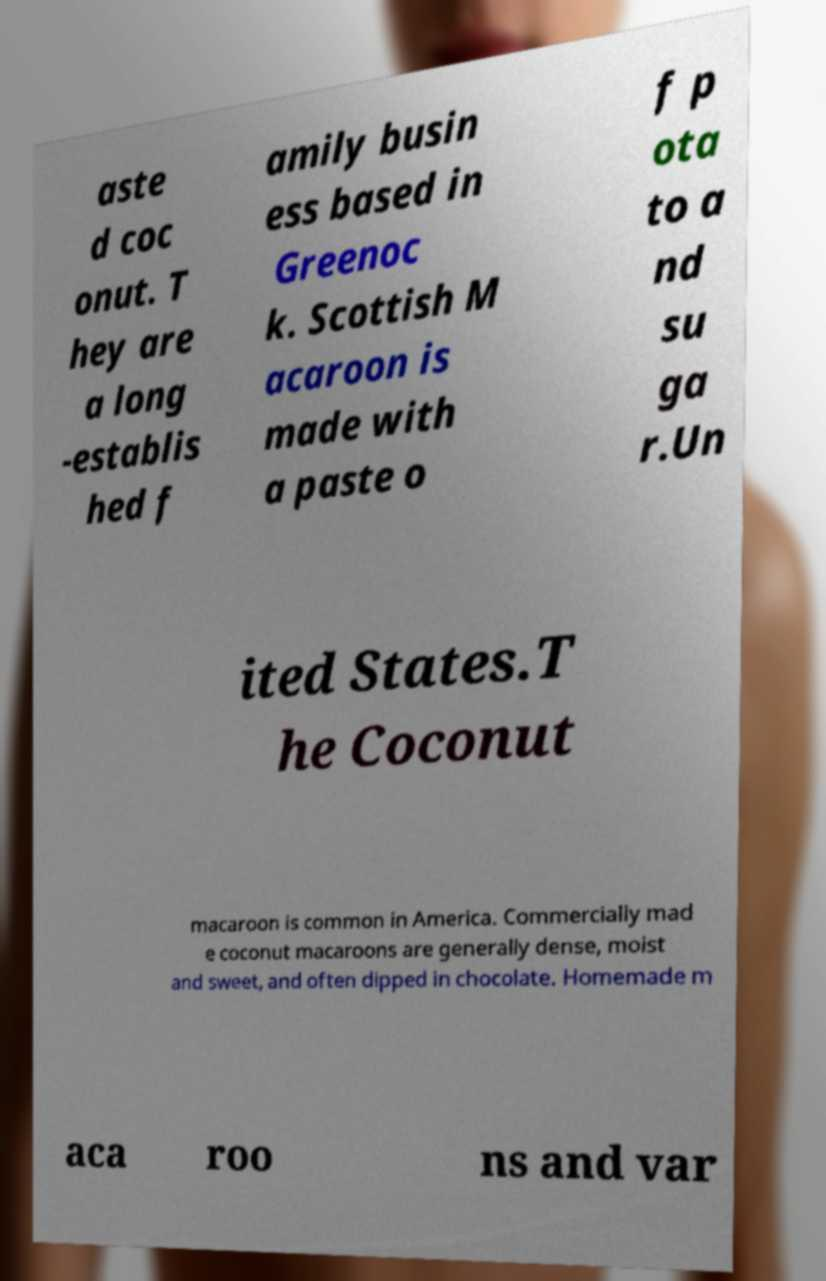Can you accurately transcribe the text from the provided image for me? aste d coc onut. T hey are a long -establis hed f amily busin ess based in Greenoc k. Scottish M acaroon is made with a paste o f p ota to a nd su ga r.Un ited States.T he Coconut macaroon is common in America. Commercially mad e coconut macaroons are generally dense, moist and sweet, and often dipped in chocolate. Homemade m aca roo ns and var 